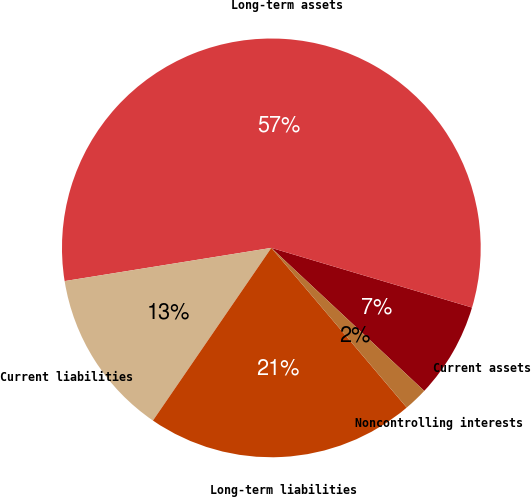Convert chart to OTSL. <chart><loc_0><loc_0><loc_500><loc_500><pie_chart><fcel>Current assets<fcel>Long-term assets<fcel>Current liabilities<fcel>Long-term liabilities<fcel>Noncontrolling interests<nl><fcel>7.37%<fcel>57.14%<fcel>12.9%<fcel>20.76%<fcel>1.84%<nl></chart> 